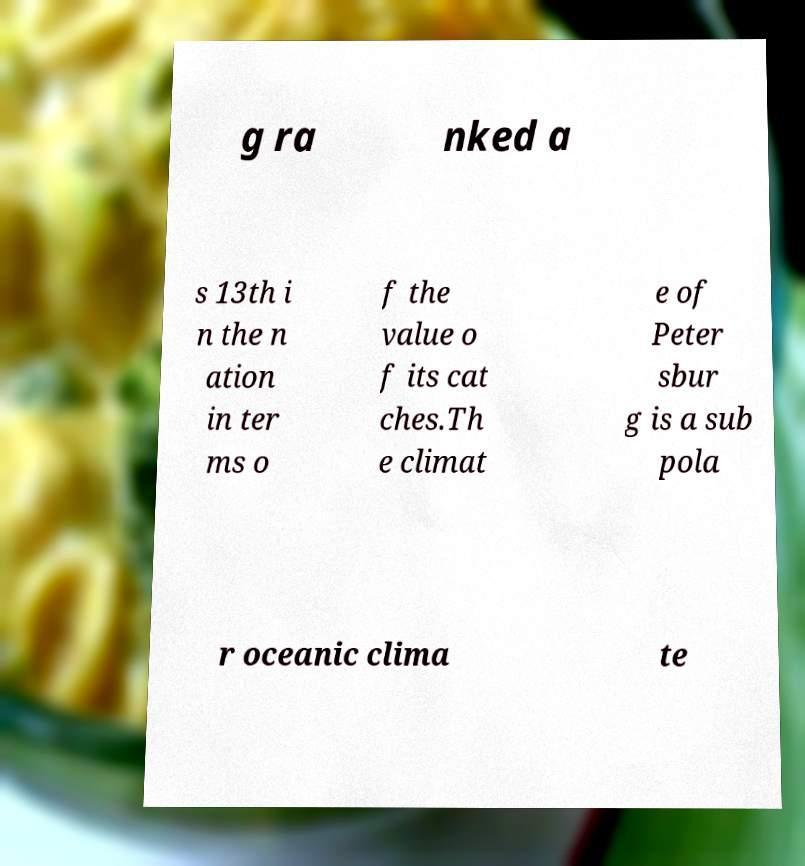Can you read and provide the text displayed in the image?This photo seems to have some interesting text. Can you extract and type it out for me? g ra nked a s 13th i n the n ation in ter ms o f the value o f its cat ches.Th e climat e of Peter sbur g is a sub pola r oceanic clima te 